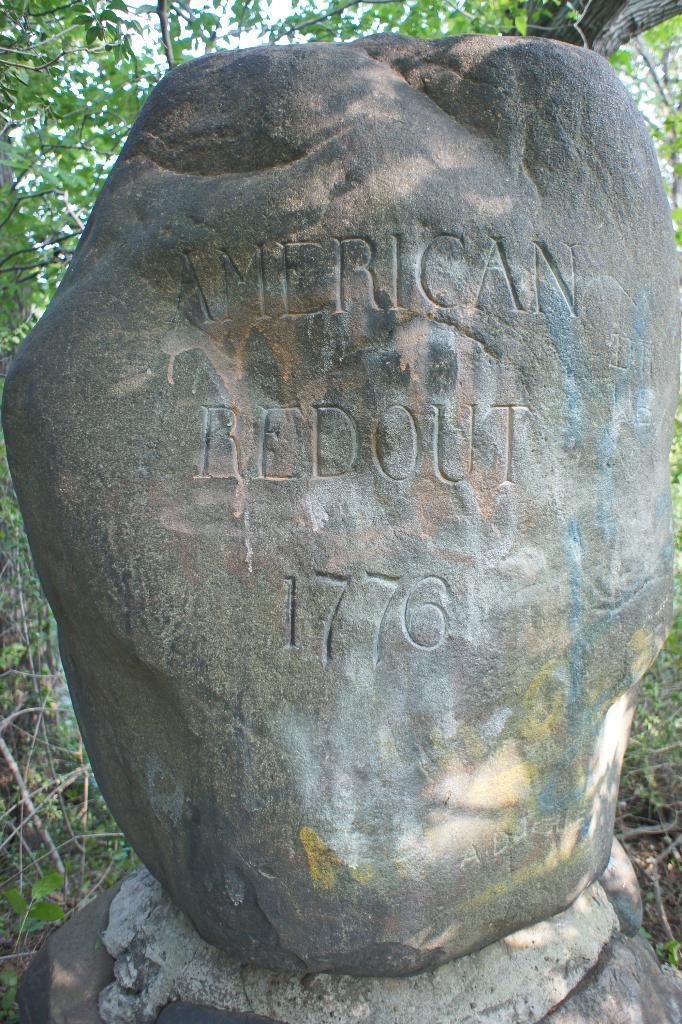Could you give a brief overview of what you see in this image? In this image we can see a rock on which some text was written. 